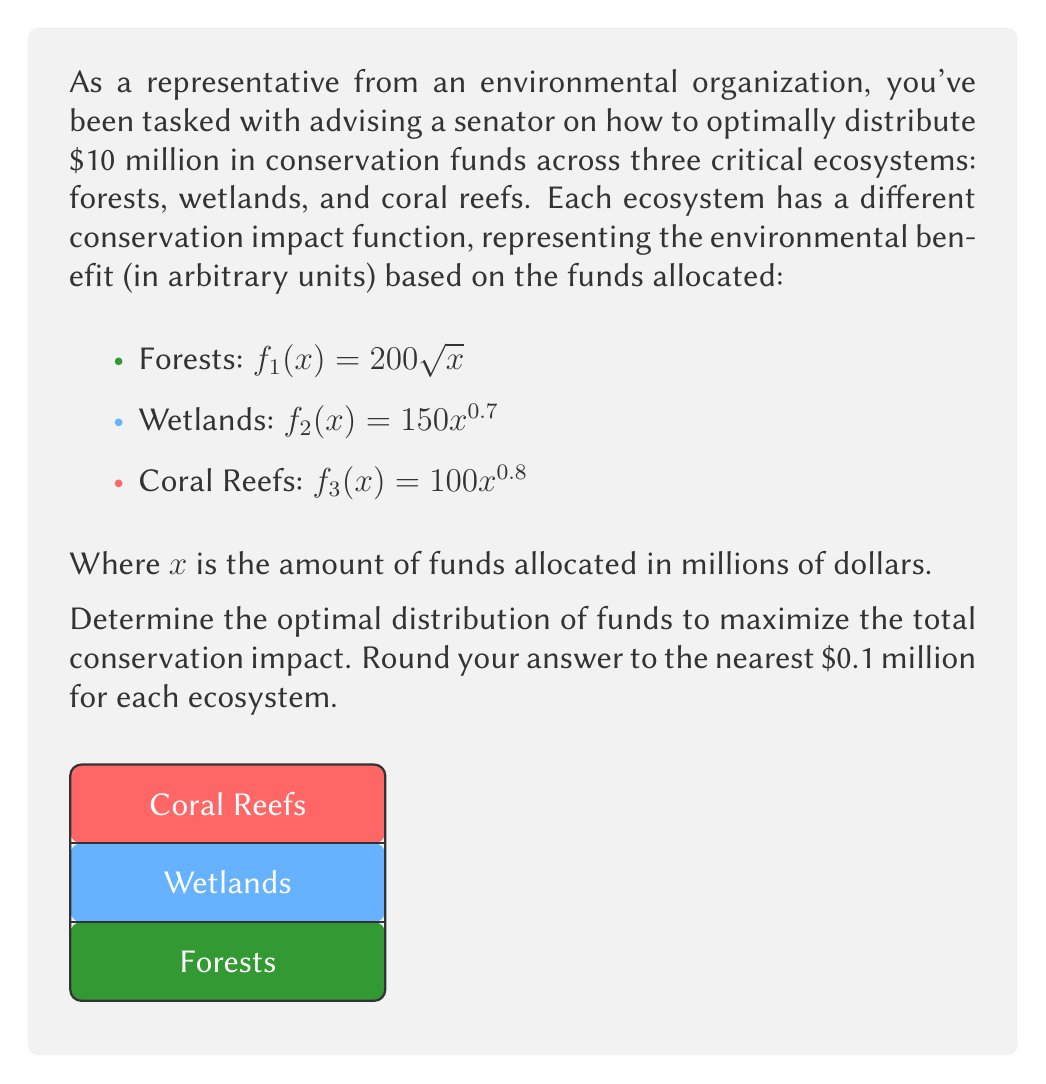Give your solution to this math problem. To solve this problem, we'll use the method of Lagrange multipliers, which is ideal for optimizing the allocation of resources under constraints.

Step 1: Define the objective function and constraint
Let $x_1$, $x_2$, and $x_3$ be the funds allocated to forests, wetlands, and coral reefs respectively.
Objective function: $F = 200\sqrt{x_1} + 150x_2^{0.7} + 100x_3^{0.8}$
Constraint: $x_1 + x_2 + x_3 = 10$

Step 2: Form the Lagrangian
$L = 200\sqrt{x_1} + 150x_2^{0.7} + 100x_3^{0.8} - \lambda(x_1 + x_2 + x_3 - 10)$

Step 3: Take partial derivatives and set them equal to zero
$$\frac{\partial L}{\partial x_1} = \frac{100}{\sqrt{x_1}} - \lambda = 0$$
$$\frac{\partial L}{\partial x_2} = 105x_2^{-0.3} - \lambda = 0$$
$$\frac{\partial L}{\partial x_3} = 80x_3^{-0.2} - \lambda = 0$$
$$\frac{\partial L}{\partial \lambda} = x_1 + x_2 + x_3 - 10 = 0$$

Step 4: Solve the system of equations
From the first three equations:
$$\frac{100}{\sqrt{x_1}} = 105x_2^{-0.3} = 80x_3^{-0.2} = \lambda$$

This implies:
$$x_1 = (\frac{100}{\lambda})^2$$
$$x_2 = (\frac{105}{\lambda})^{10/3}$$
$$x_3 = (\frac{80}{\lambda})^5$$

Substituting these into the constraint equation:
$$(\frac{100}{\lambda})^2 + (\frac{105}{\lambda})^{10/3} + (\frac{80}{\lambda})^5 = 10$$

Solving this numerically (as it's not easily solvable analytically), we get:
$\lambda \approx 70.71$

Step 5: Calculate the optimal allocation
$$x_1 \approx 2.0 \text{ million}$$
$$x_2 \approx 3.7 \text{ million}$$
$$x_3 \approx 4.3 \text{ million}$$

Rounding to the nearest 0.1 million as requested:
Forests: $2.0 million
Wetlands: $3.7 million
Coral Reefs: $4.3 million
Answer: Forests: $2.0 million, Wetlands: $3.7 million, Coral Reefs: $4.3 million 